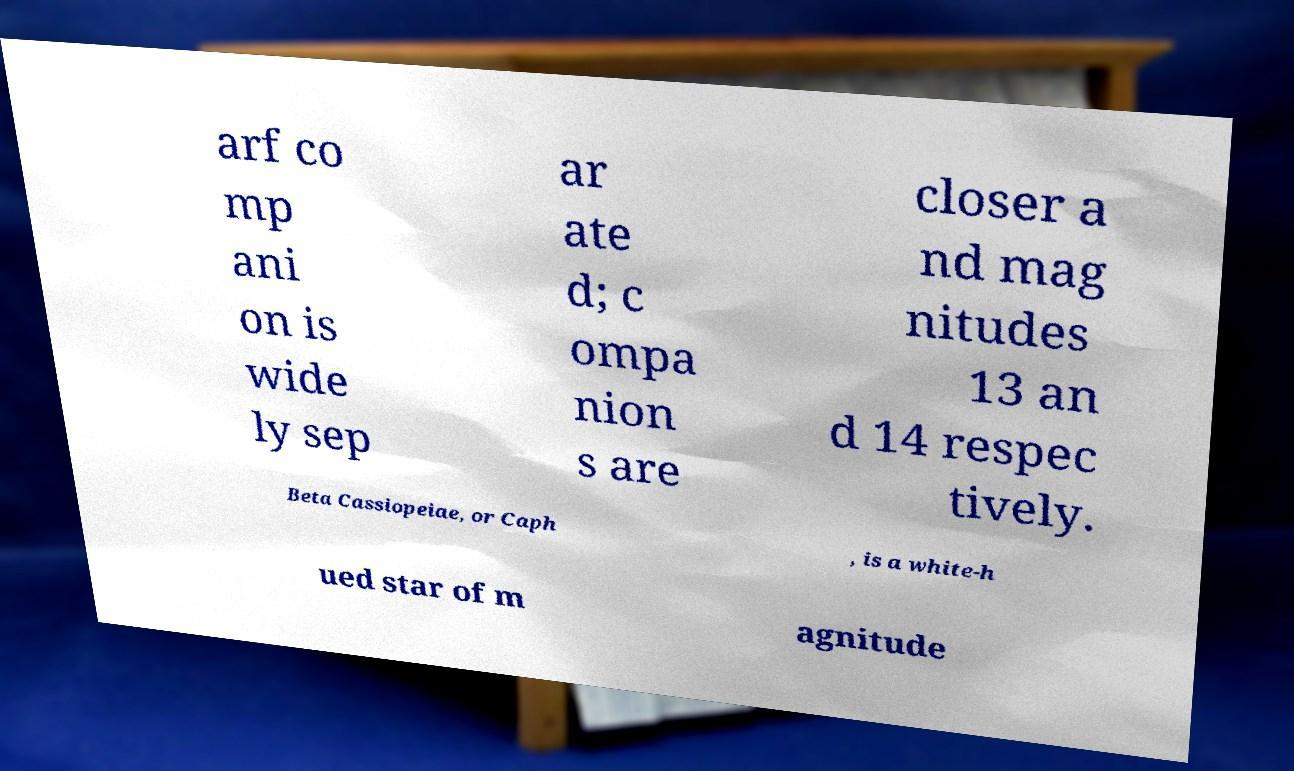What messages or text are displayed in this image? I need them in a readable, typed format. arf co mp ani on is wide ly sep ar ate d; c ompa nion s are closer a nd mag nitudes 13 an d 14 respec tively. Beta Cassiopeiae, or Caph , is a white-h ued star of m agnitude 